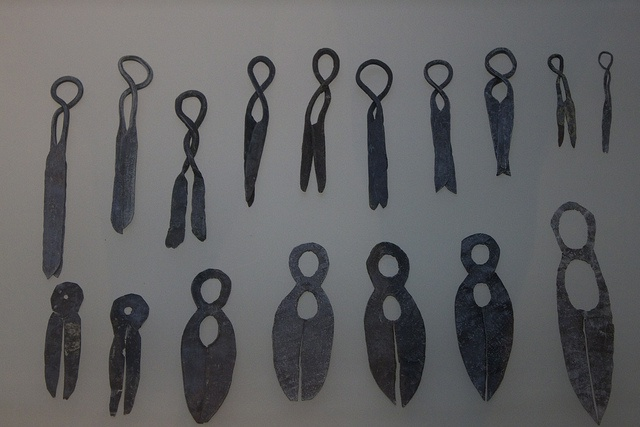Describe the objects in this image and their specific colors. I can see scissors in gray and black tones, scissors in gray and black tones, scissors in gray and black tones, scissors in gray and black tones, and scissors in gray and black tones in this image. 